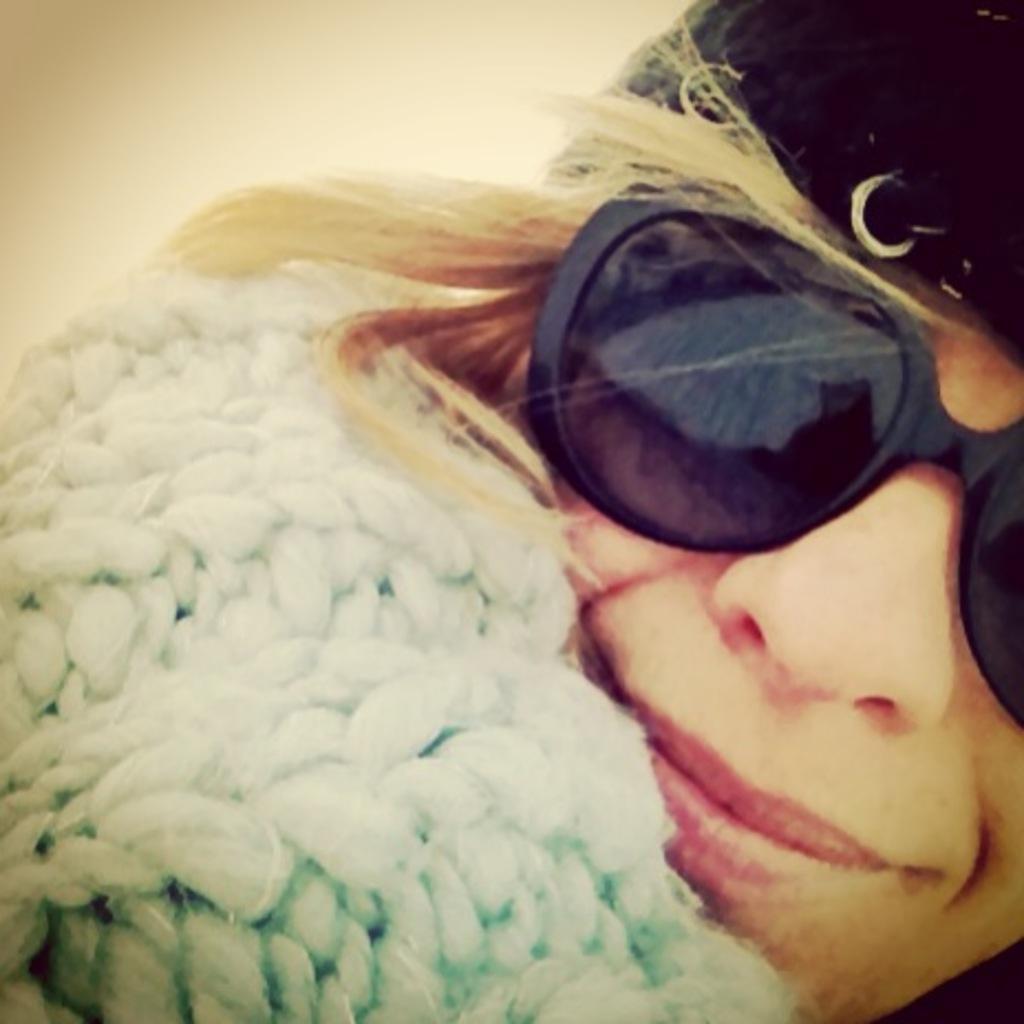Could you give a brief overview of what you see in this image? In this picture we can see a person wearing goggles on the eyes and a cap on the head. 